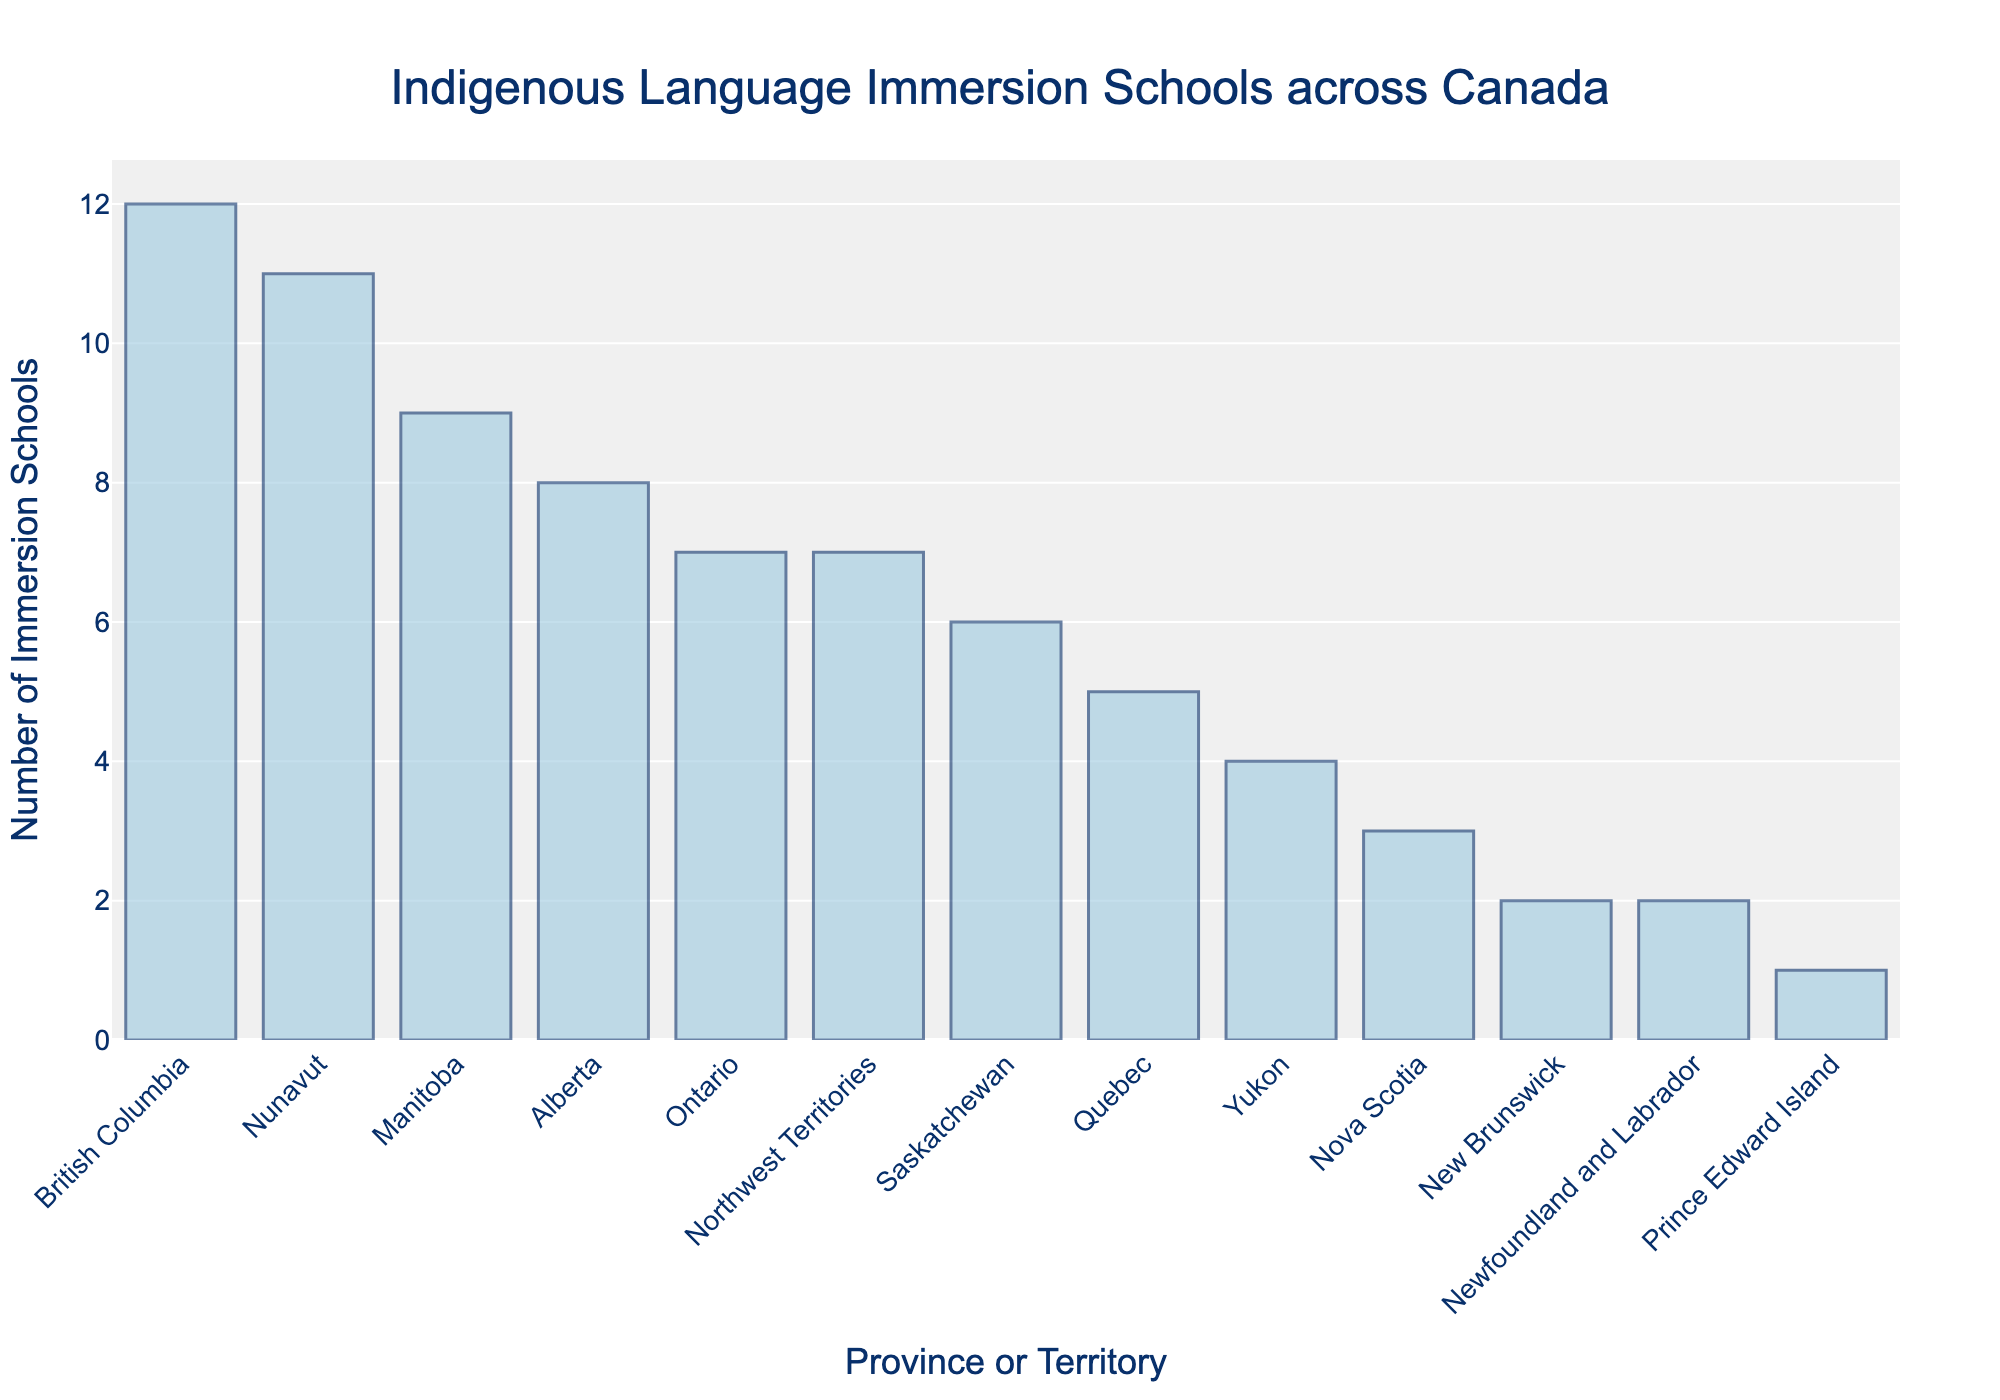Which province or territory has the highest number of Indigenous language immersion schools? Looking at the heights of the bars in the chart, British Columbia has the tallest bar indicating the highest number of immersion schools.
Answer: British Columbia Which two provinces or territories have the least number of Indigenous language immersion schools? The shortest bars on the chart represent the entities with the least number of schools. Prince Edward Island and Newfoundland and Labrador have the shortest bars.
Answer: Prince Edward Island, Newfoundland and Labrador How many more Indigenous language immersion schools are there in British Columbia compared to Quebec? The heights of the bars for British Columbia and Quebec show their number of schools. British Columbia has 12 schools, and Quebec has 5 schools. The difference is calculated as 12 - 5.
Answer: 7 List all provinces or territories with more than 7 Indigenous language immersion schools. By examining the heights of the bars and their corresponding labels, provinces or territories with bars taller than 7 units on the y-axis are British Columbia, Alberta, Manitoba, Nunavut, Northwest Territories.
Answer: British Columbia, Alberta, Manitoba, Nunavut, Northwest Territories What is the total number of Indigenous language immersion schools in the three territories (Yukon, Northwest Territories, and Nunavut)? Add the number of schools in each territory: Yukon has 4, Northwest Territories has 7, and Nunavut has 11. Sum these numbers.
Answer: 22 What is the average number of Indigenous language immersion schools in the Atlantic provinces (New Brunswick, Nova Scotia, Newfoundland and Labrador, Prince Edward Island)? Add the number of schools in these provinces and divide by the number of provinces. They have 2, 3, 2, and 1 schools, respectively. So, (2 + 3 + 2 + 1)/4 = 2.
Answer: 2 Compare the number of Indigenous language immersion schools between Alberta and Ontario. Which has more? Look at the height of the bars for Alberta and Ontario. Alberta has 8 schools, and Ontario has 7 schools. Alberta has more.
Answer: Alberta What is the sum of Indigenous language immersion schools in Manitoba and Saskatchewan? Add the number of schools in Manitoba and Saskatchewan. Manitoba has 9 schools, and Saskatchewan has 6 schools. So, 9 + 6.
Answer: 15 Which province or territory has the third highest number of Indigenous language immersion schools? Rank the heights of the bars and identify the third tallest bar. Nunavut is the second highest, and Manitoba is the third highest.
Answer: Manitoba Identify the central Canadian provinces and their count of Indigenous language immersion schools. Central Canadian provinces are typically considered to be Manitoba, Ontario, and Quebec. Manitoba has 9 schools, Ontario has 7 schools, and Quebec has 5 schools.
Answer: Manitoba: 9, Ontario: 7, Quebec: 5 